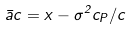Convert formula to latex. <formula><loc_0><loc_0><loc_500><loc_500>\bar { a } c = x - \sigma ^ { 2 } c _ { P } / c</formula> 